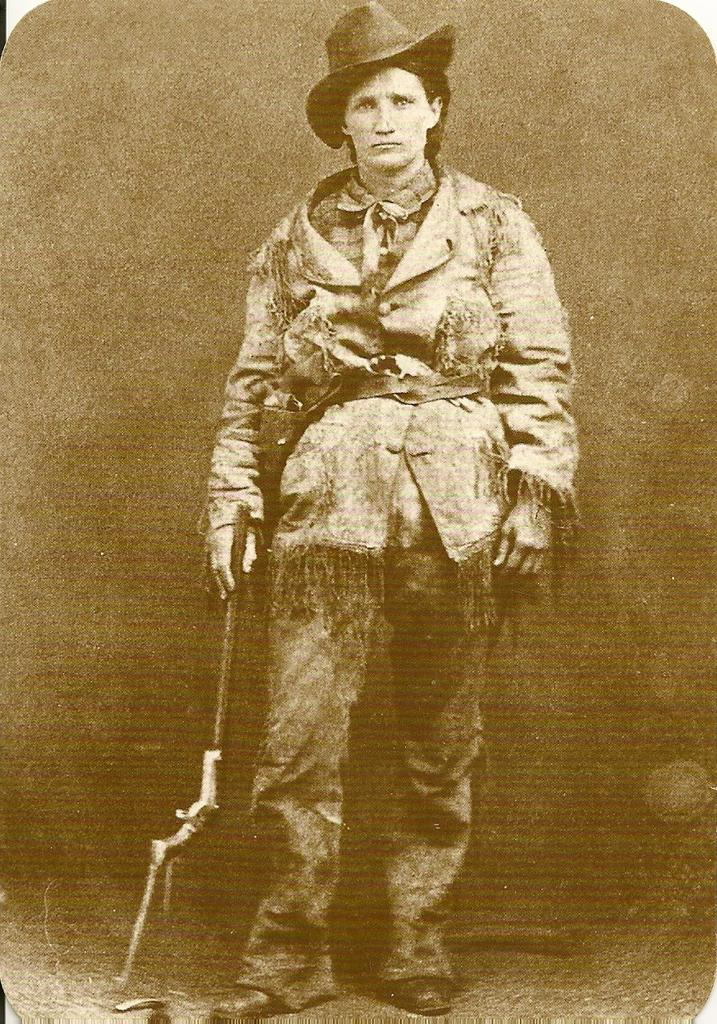What can be seen in the image? There is a person in the image. What is the person holding in the image? The person is holding an object. Can you describe the person's attire in the image? The person is wearing a hat. How many toes can be seen in the image? There are no toes visible in the image, as it only features a person holding an object and wearing a hat. 